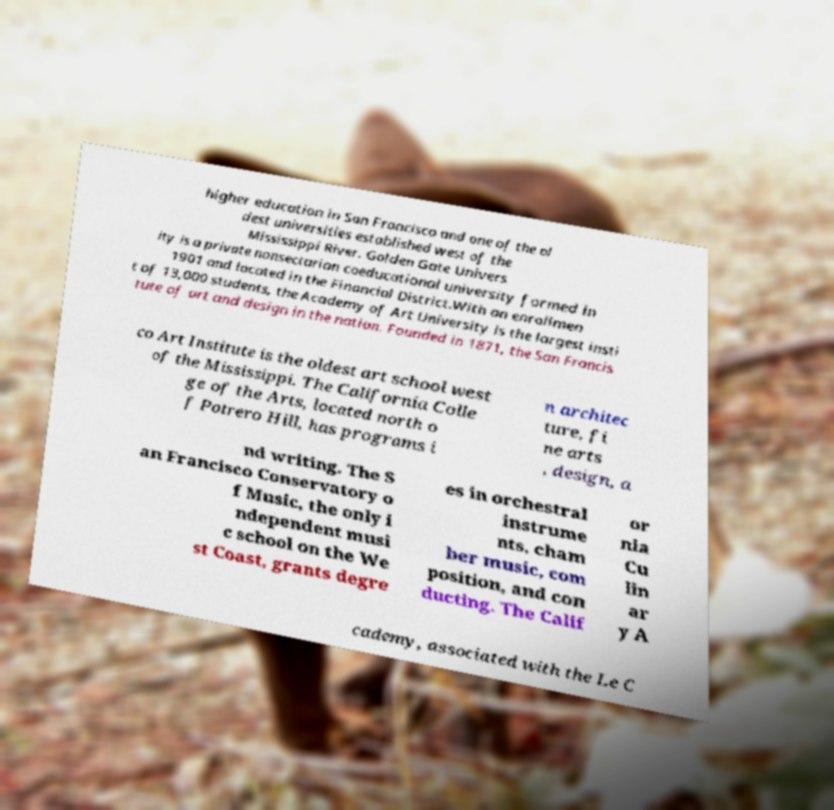I need the written content from this picture converted into text. Can you do that? higher education in San Francisco and one of the ol dest universities established west of the Mississippi River. Golden Gate Univers ity is a private nonsectarian coeducational university formed in 1901 and located in the Financial District.With an enrollmen t of 13,000 students, the Academy of Art University is the largest insti tute of art and design in the nation. Founded in 1871, the San Francis co Art Institute is the oldest art school west of the Mississippi. The California Colle ge of the Arts, located north o f Potrero Hill, has programs i n architec ture, fi ne arts , design, a nd writing. The S an Francisco Conservatory o f Music, the only i ndependent musi c school on the We st Coast, grants degre es in orchestral instrume nts, cham ber music, com position, and con ducting. The Calif or nia Cu lin ar y A cademy, associated with the Le C 